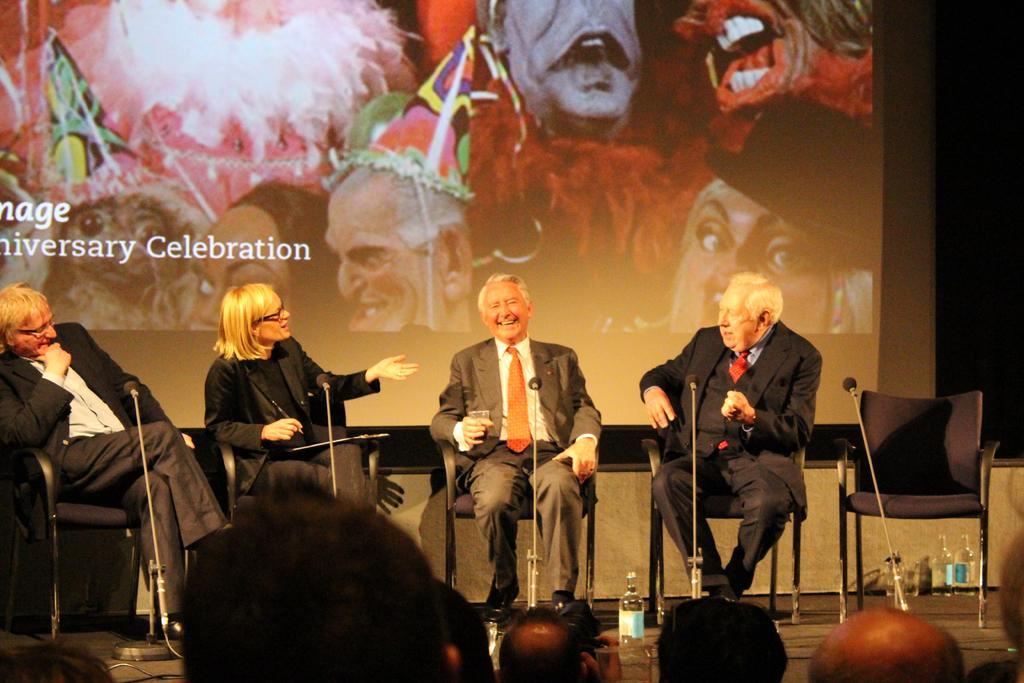Describe this image in one or two sentences. In this picture I can observe four members sitting in the chairs on the stage. Three of them are men and one of them is a woman. In front of them there are mics. On the bottom of the picture I can observe some people in front of the stage. In the background there is a screen. 